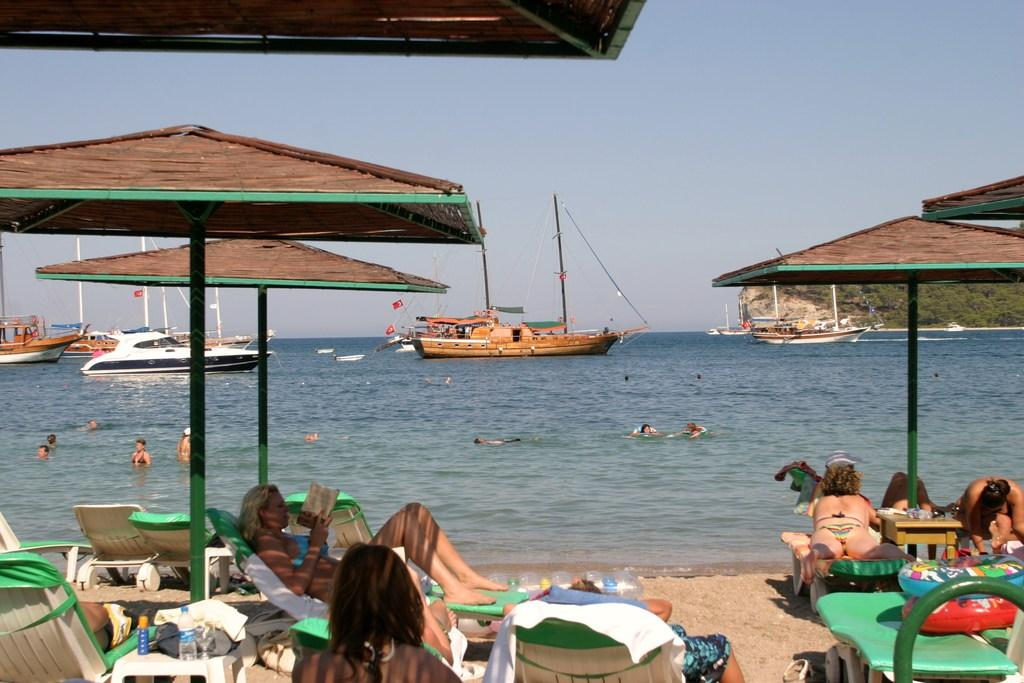What is happening in the image involving a group of people? The people in the image are lying on chairs. Can you describe the setting in which the people are lying on chairs? The image shows a waterfront setting, with ships visible on the water. What type of distribution system is being used by the people in the image? There is no distribution system mentioned or visible in the image; the people are simply lying on chairs. 